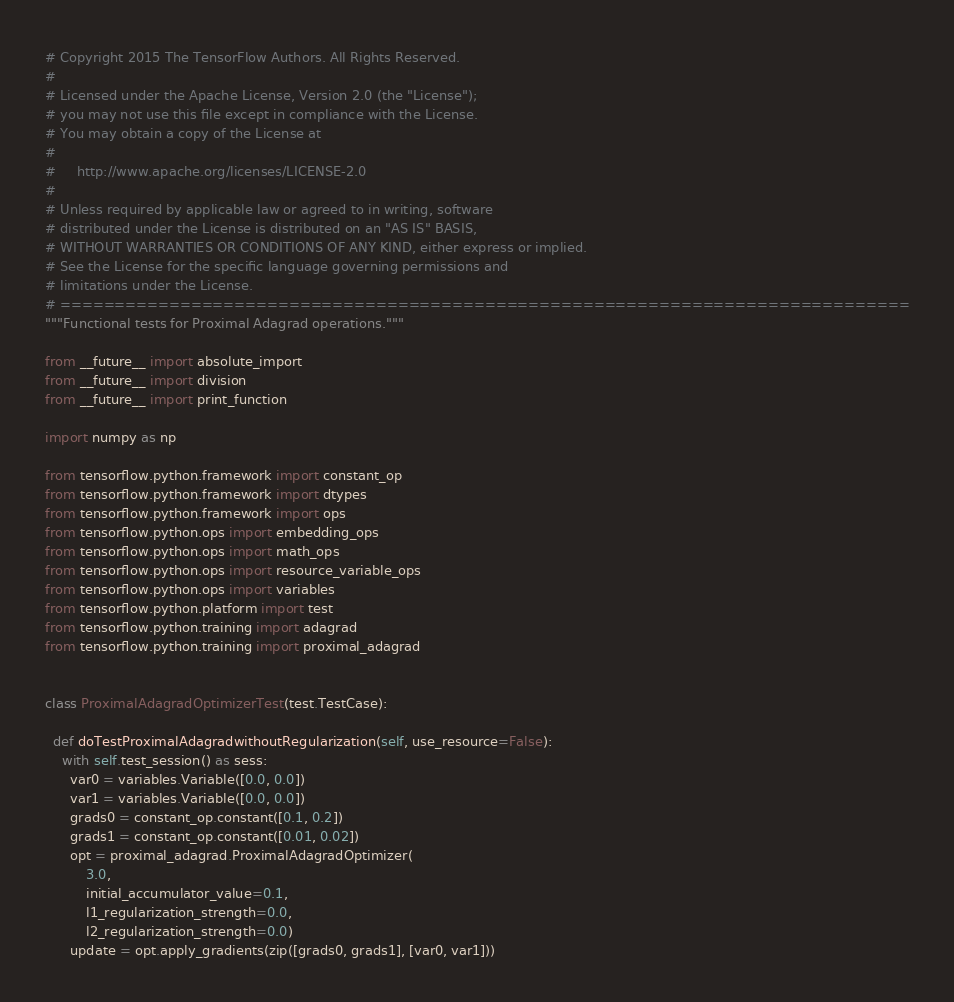<code> <loc_0><loc_0><loc_500><loc_500><_Python_># Copyright 2015 The TensorFlow Authors. All Rights Reserved.
#
# Licensed under the Apache License, Version 2.0 (the "License");
# you may not use this file except in compliance with the License.
# You may obtain a copy of the License at
#
#     http://www.apache.org/licenses/LICENSE-2.0
#
# Unless required by applicable law or agreed to in writing, software
# distributed under the License is distributed on an "AS IS" BASIS,
# WITHOUT WARRANTIES OR CONDITIONS OF ANY KIND, either express or implied.
# See the License for the specific language governing permissions and
# limitations under the License.
# ==============================================================================
"""Functional tests for Proximal Adagrad operations."""

from __future__ import absolute_import
from __future__ import division
from __future__ import print_function

import numpy as np

from tensorflow.python.framework import constant_op
from tensorflow.python.framework import dtypes
from tensorflow.python.framework import ops
from tensorflow.python.ops import embedding_ops
from tensorflow.python.ops import math_ops
from tensorflow.python.ops import resource_variable_ops
from tensorflow.python.ops import variables
from tensorflow.python.platform import test
from tensorflow.python.training import adagrad
from tensorflow.python.training import proximal_adagrad


class ProximalAdagradOptimizerTest(test.TestCase):

  def doTestProximalAdagradwithoutRegularization(self, use_resource=False):
    with self.test_session() as sess:
      var0 = variables.Variable([0.0, 0.0])
      var1 = variables.Variable([0.0, 0.0])
      grads0 = constant_op.constant([0.1, 0.2])
      grads1 = constant_op.constant([0.01, 0.02])
      opt = proximal_adagrad.ProximalAdagradOptimizer(
          3.0,
          initial_accumulator_value=0.1,
          l1_regularization_strength=0.0,
          l2_regularization_strength=0.0)
      update = opt.apply_gradients(zip([grads0, grads1], [var0, var1]))</code> 